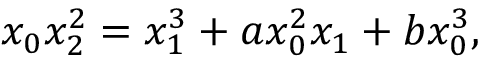<formula> <loc_0><loc_0><loc_500><loc_500>x _ { 0 } x _ { 2 } ^ { 2 } = x _ { 1 } ^ { 3 } + a x _ { 0 } ^ { 2 } x _ { 1 } + b x _ { 0 } ^ { 3 } ,</formula> 